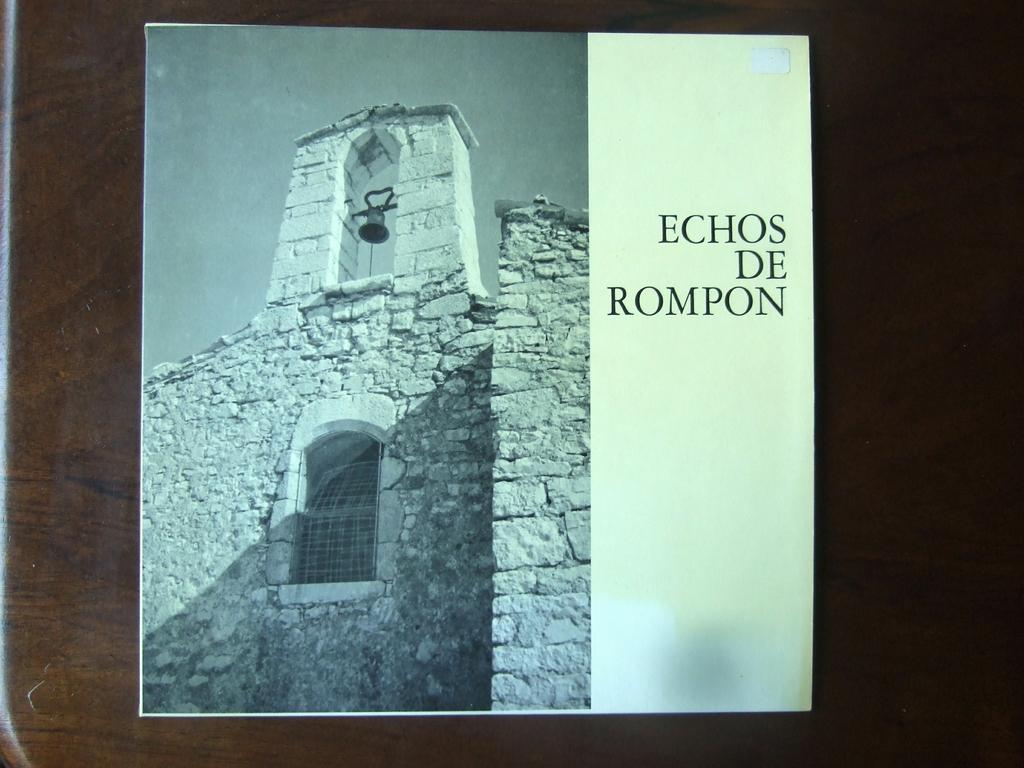What is the name of the bell tower?
Ensure brevity in your answer.  Echos de rompon. 